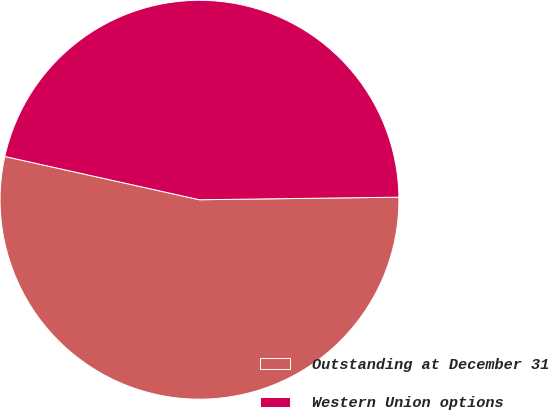Convert chart to OTSL. <chart><loc_0><loc_0><loc_500><loc_500><pie_chart><fcel>Outstanding at December 31<fcel>Western Union options<nl><fcel>53.69%<fcel>46.31%<nl></chart> 